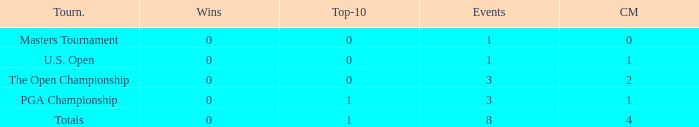For more than 3 events in the PGA Championship, what is the fewest number of wins? None. 